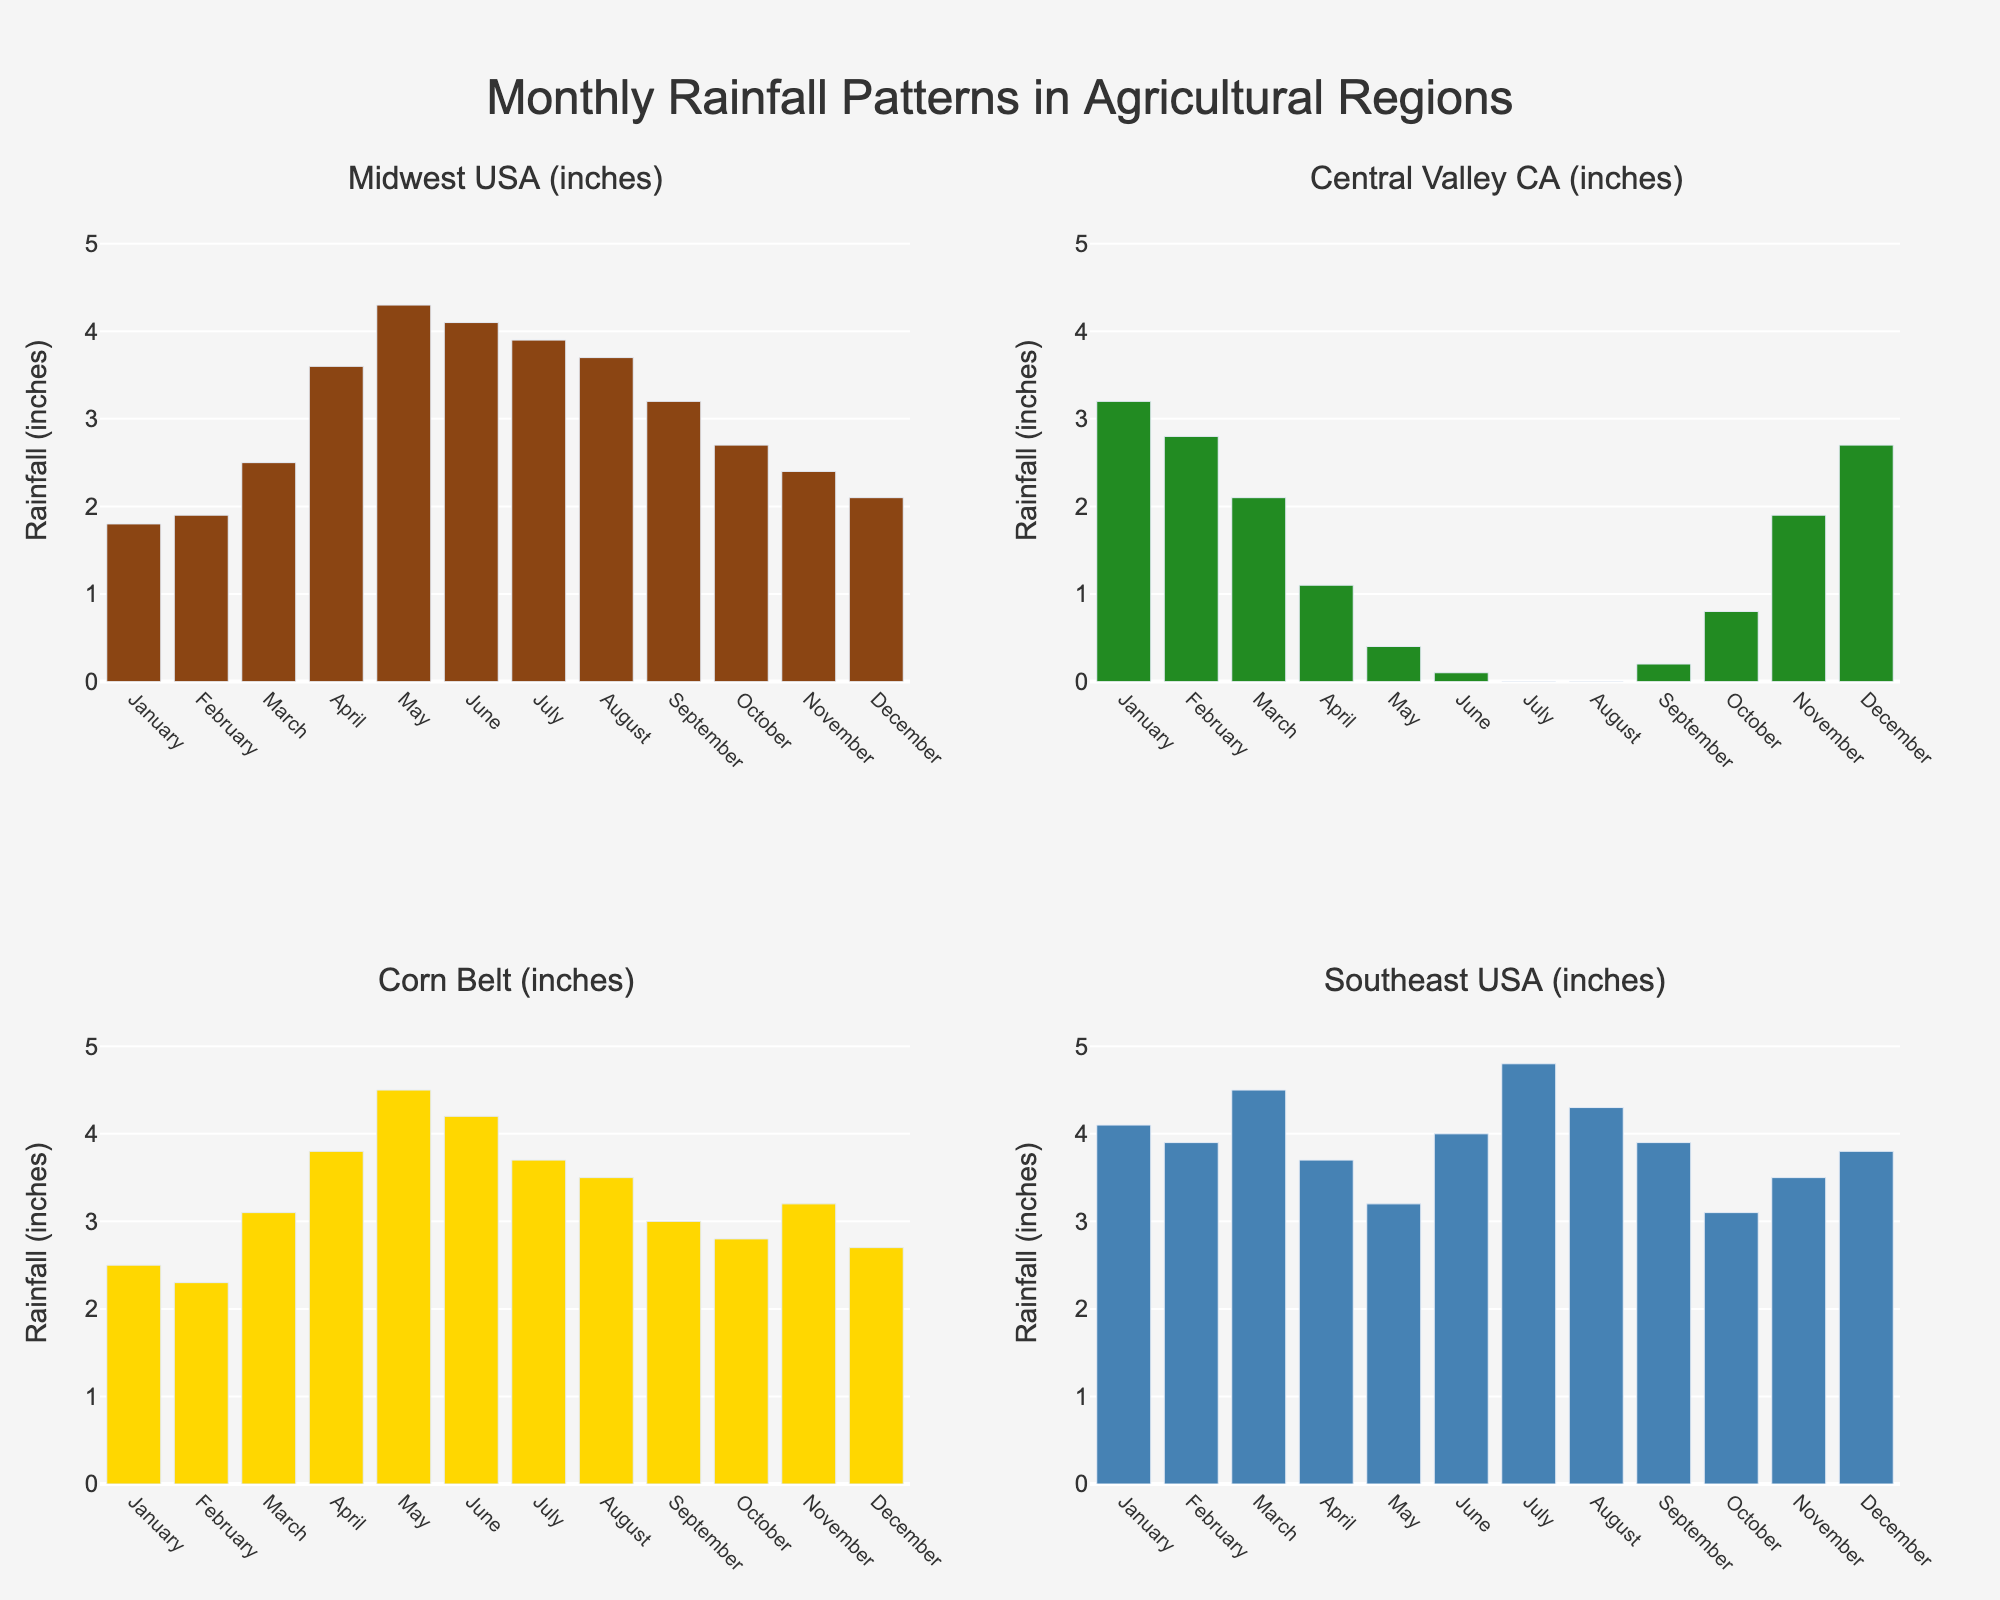What is the total rainfall in the Midwest USA during the summer months (June, July, August)? To find the total rainfall for the Midwest USA during June, July, and August, add the rainfall values for these months: 4.1 + 3.9 + 3.7 = 11.7 inches.
Answer: 11.7 inches Which region has the highest rainfall in April? Compare the rainfall values of April for all regions: Midwest USA (3.6), Central Valley CA (1.1), Corn Belt (3.8), Southeast USA (3.7). The Corn Belt has the highest value.
Answer: Corn Belt In which month does the Central Valley of California receive no rainfall? By looking at the rainfall bars for the Central Valley of California, check for the month(s) with a value of 0 inches. July and August have no rainfall.
Answer: July and August What is the difference in rainfall between September and December for the Southeast USA? Subtract the rainfall of December from September for the Southeast USA: 3.9 - 3.8 = 0.1 inches.
Answer: 0.1 inches Which region has the most consistent rainfall, with the least variance throughout the year? To determine variance, visually compare the height of bars for each region: Midwest USA, Central Valley CA, Corn Belt, and Southeast USA. The Southeast USA has the least variance, having more consistent bar heights.
Answer: Southeast USA What is the average monthly rainfall for the Corn Belt? Sum up the monthly rainfall values for the Corn Belt and divide by 12. (2.5 + 2.3 + 3.1 + 3.8 + 4.5 + 4.2 + 3.7 + 3.5 + 3.0 + 2.8 + 3.2 + 2.7) / 12 = 39.3 / 12 = 3.275 inches.
Answer: 3.275 inches Which month has the highest combined (total) rainfall across all regions? Sum the values for each month across regions and find the maximum. January (11.6), February (10.9), March (12.2), April (12.2), May (12.4), June (12.4), July (12.4), August (11.5), September (10.3), October (9.4), November (11.0), December (11.3). June, July, and May all have the highest combined rainfall at 12.4 inches.
Answer: June, July, and May 